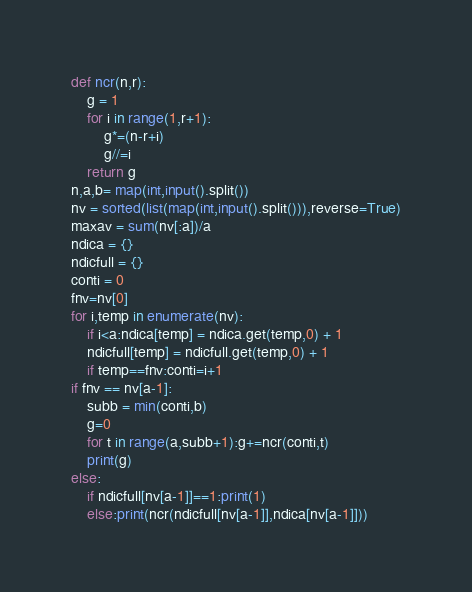Convert code to text. <code><loc_0><loc_0><loc_500><loc_500><_Python_>def ncr(n,r):
    g = 1
    for i in range(1,r+1):
        g*=(n-r+i)
        g//=i
    return g
n,a,b= map(int,input().split())
nv = sorted(list(map(int,input().split())),reverse=True)
maxav = sum(nv[:a])/a
ndica = {}
ndicfull = {}
conti = 0
fnv=nv[0]
for i,temp in enumerate(nv):
    if i<a:ndica[temp] = ndica.get(temp,0) + 1
    ndicfull[temp] = ndicfull.get(temp,0) + 1
    if temp==fnv:conti=i+1
if fnv == nv[a-1]:
    subb = min(conti,b)
    g=0
    for t in range(a,subb+1):g+=ncr(conti,t)
    print(g)
else:
    if ndicfull[nv[a-1]]==1:print(1)
    else:print(ncr(ndicfull[nv[a-1]],ndica[nv[a-1]]))</code> 